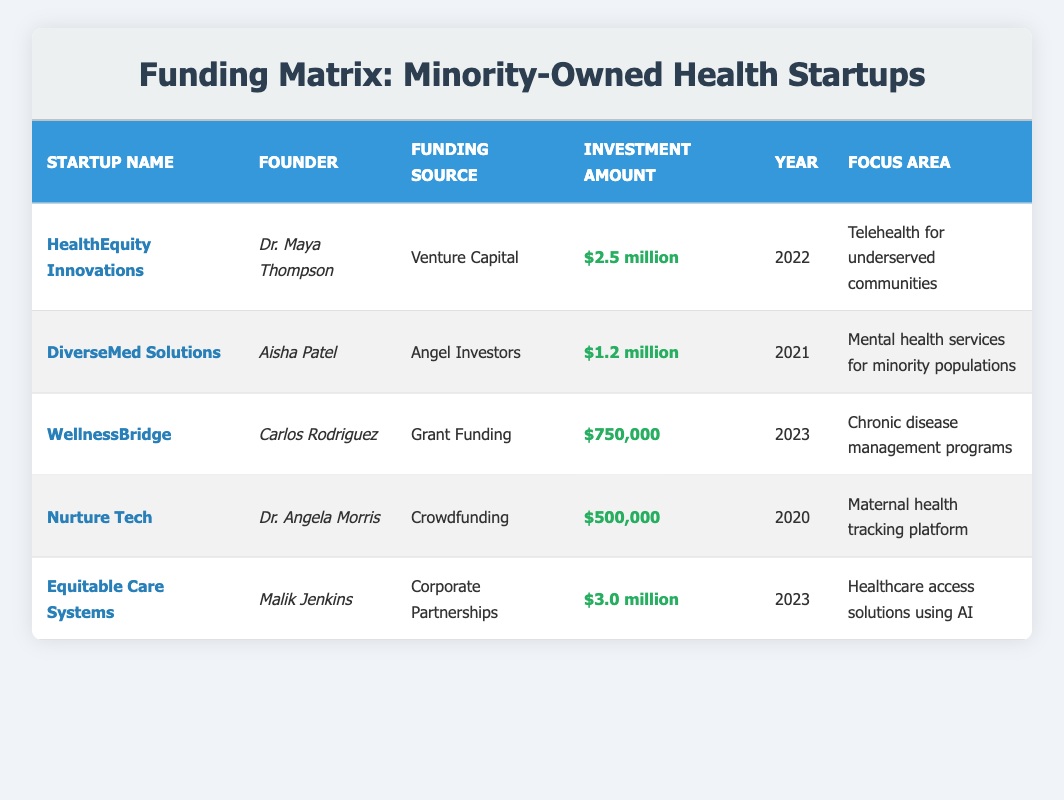What is the funding source for HealthEquity Innovations? HealthEquity Innovations has "Venture Capital" listed as its funding source in the table.
Answer: Venture Capital Which startup received the highest investment amount? The startup with the highest investment amount is "Equitable Care Systems," which received "$3.0 million."
Answer: Equitable Care Systems How many startups were funded in the year 2023? There are two startups listed with funding in the year 2023: "WellnessBridge" and "Equitable Care Systems."
Answer: 2 What is the total investment amount for startups that focus on mental health services? There is one startup focusing on mental health services, "DiverseMed Solutions," which received "$1.2 million." The total investment amount is therefore $1.2 million.
Answer: $1.2 million Did any startup receive funding from Angel Investors? Yes, the startup "DiverseMed Solutions" received funding from Angel Investors.
Answer: Yes What is the average investment amount across all listed startups? The investment amounts are $2.5 million, $1.2 million, $750,000, $500,000, and $3.0 million. First, convert them to numbers: (2.5 + 1.2 + 0.75 + 0.5 + 3) million = 8.97 million. There are 5 startups, thus the average investment amount is 8.97 / 5 = 1.794 million.
Answer: $1.794 million How many different funding sources are represented in the table? The table lists five unique funding sources: Venture Capital, Angel Investors, Grant Funding, Crowdfunding, and Corporate Partnerships, making a total of 5 distinct types.
Answer: 5 Which founder is associated with the startup focusing on chronic disease management? The founder associated with "WellnessBridge," which focuses on chronic disease management, is Carlos Rodriguez.
Answer: Carlos Rodriguez What percentage of the total funding is contributed by the startup with the lowest investment amount? The lowest investment amount is "$500,000" from "Nurture Tech." The total investments are $2.5 million + $1.2 million + $750,000 + $500,000 + $3.0 million, which sums to $8.97 million. The percentage is (0.5 / 8.97) * 100 ≈ 5.57%.
Answer: 5.57% 